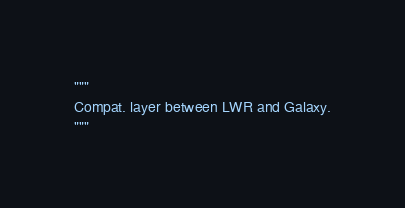Convert code to text. <code><loc_0><loc_0><loc_500><loc_500><_Python_>"""
Compat. layer between LWR and Galaxy.
"""
</code> 